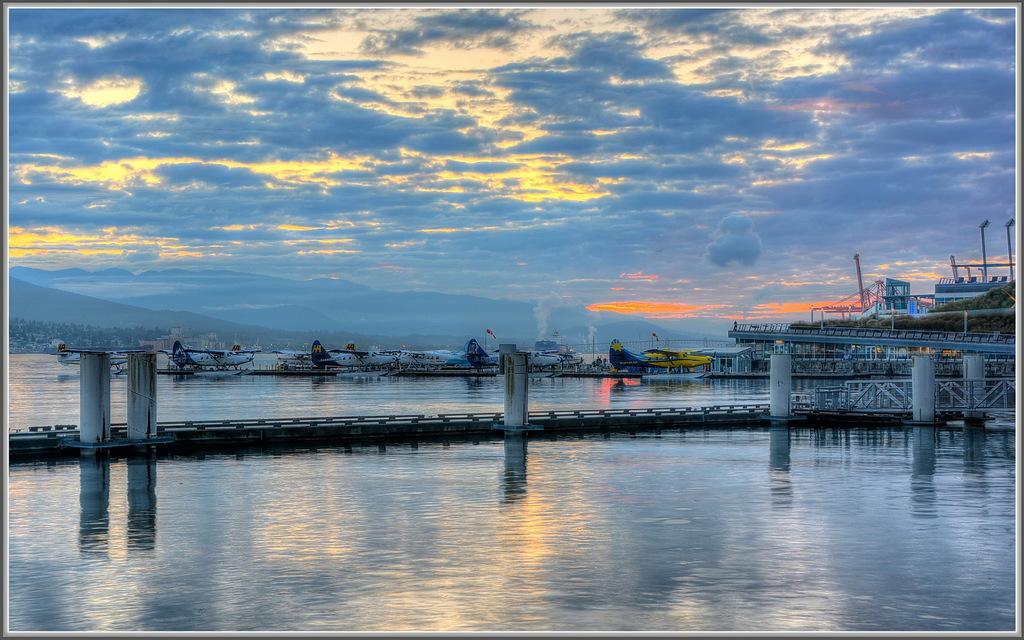Can you describe this image briefly? In this picture I can observe river in the middle of the picture. I can observe airplanes in the middle of the picture. In the background there are some clouds in the sky. 